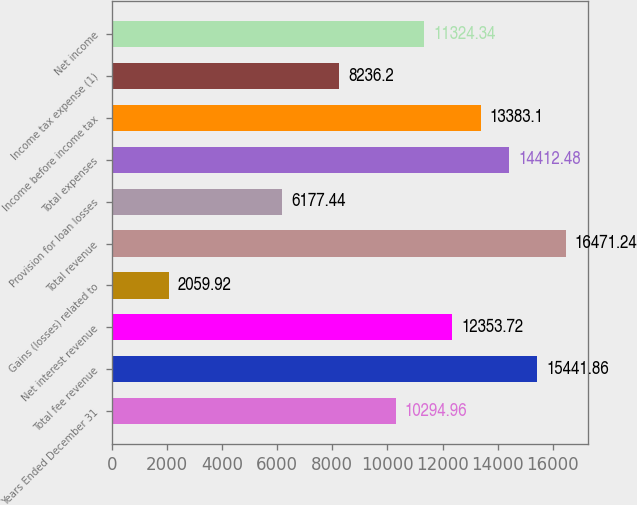<chart> <loc_0><loc_0><loc_500><loc_500><bar_chart><fcel>Years Ended December 31<fcel>Total fee revenue<fcel>Net interest revenue<fcel>Gains (losses) related to<fcel>Total revenue<fcel>Provision for loan losses<fcel>Total expenses<fcel>Income before income tax<fcel>Income tax expense (1)<fcel>Net income<nl><fcel>10295<fcel>15441.9<fcel>12353.7<fcel>2059.92<fcel>16471.2<fcel>6177.44<fcel>14412.5<fcel>13383.1<fcel>8236.2<fcel>11324.3<nl></chart> 